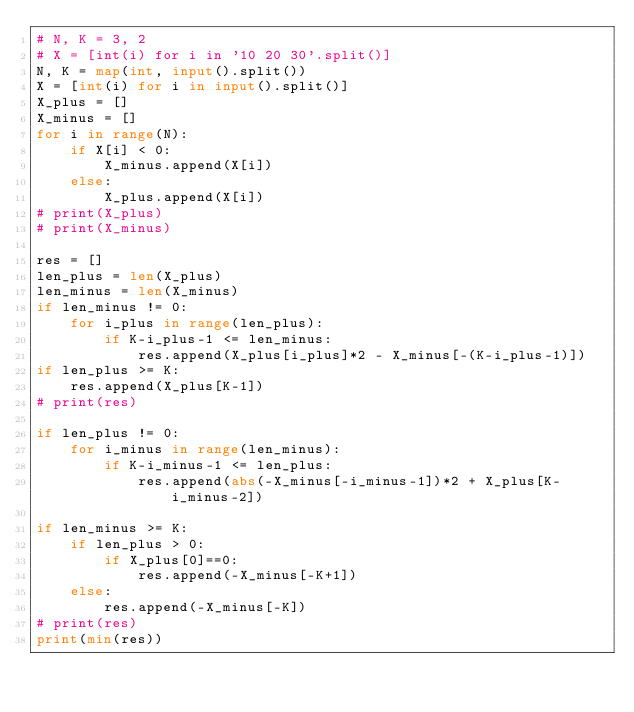<code> <loc_0><loc_0><loc_500><loc_500><_Python_># N, K = 3, 2
# X = [int(i) for i in '10 20 30'.split()]
N, K = map(int, input().split())
X = [int(i) for i in input().split()]
X_plus = []
X_minus = []
for i in range(N):
    if X[i] < 0:
        X_minus.append(X[i])
    else:
        X_plus.append(X[i])
# print(X_plus)
# print(X_minus)

res = []
len_plus = len(X_plus)
len_minus = len(X_minus)
if len_minus != 0:
    for i_plus in range(len_plus):
        if K-i_plus-1 <= len_minus:
            res.append(X_plus[i_plus]*2 - X_minus[-(K-i_plus-1)])
if len_plus >= K:
    res.append(X_plus[K-1])
# print(res)

if len_plus != 0:
    for i_minus in range(len_minus):
        if K-i_minus-1 <= len_plus:
            res.append(abs(-X_minus[-i_minus-1])*2 + X_plus[K-i_minus-2])

if len_minus >= K:
    if len_plus > 0:
        if X_plus[0]==0:
            res.append(-X_minus[-K+1])
    else:
        res.append(-X_minus[-K])
# print(res)
print(min(res))</code> 